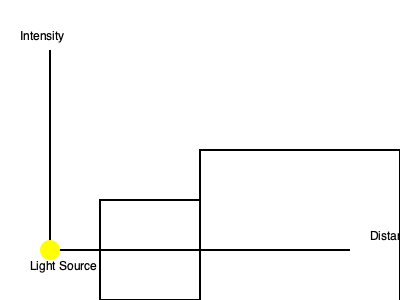As a professional photographer, you're aware that light intensity decreases with distance according to the inverse square law. In the diagram, if the light intensity at Distance 1 is 100 units, what would be the light intensity at Distance 2, which is twice as far from the light source? To solve this problem, we need to apply the inverse square law of light. This law states that the intensity of light is inversely proportional to the square of the distance from the source. Let's break it down step-by-step:

1. The inverse square law is expressed mathematically as:

   $$ I \propto \frac{1}{d^2} $$

   Where $I$ is the intensity and $d$ is the distance from the light source.

2. We're given that the intensity at Distance 1 is 100 units. Let's call this intensity $I_1$ and the distance $d_1$.

3. Distance 2 is twice as far as Distance 1, so we can express it as $2d_1$.

4. We need to find the intensity at Distance 2, let's call it $I_2$.

5. Using the inverse square law, we can set up the following proportion:

   $$ \frac{I_1}{I_2} = \frac{(2d_1)^2}{d_1^2} $$

6. Simplify the right side:

   $$ \frac{I_1}{I_2} = \frac{4d_1^2}{d_1^2} = 4 $$

7. This means that $I_1$ is 4 times $I_2$. Since $I_1 = 100$, we can solve for $I_2$:

   $$ I_2 = \frac{I_1}{4} = \frac{100}{4} = 25 $$

Therefore, the light intensity at Distance 2 would be 25 units.
Answer: 25 units 